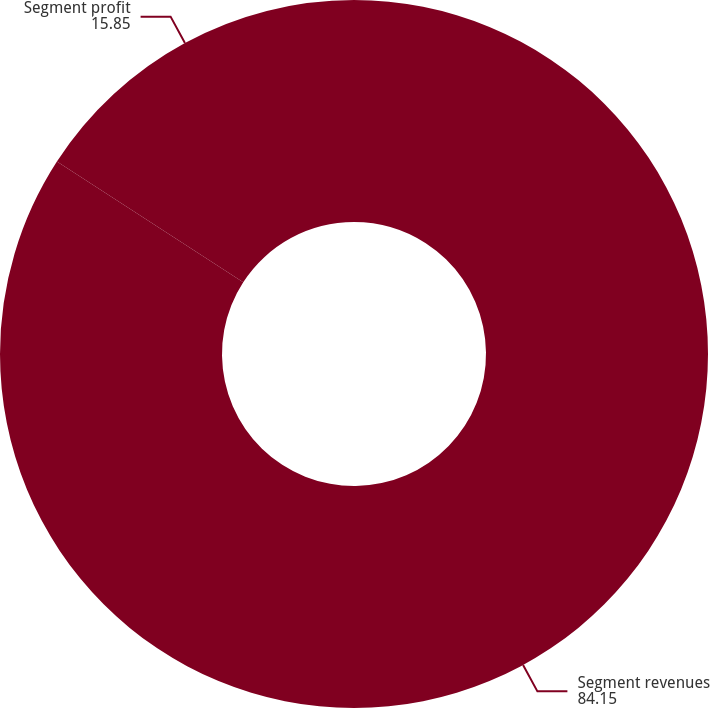<chart> <loc_0><loc_0><loc_500><loc_500><pie_chart><fcel>Segment revenues<fcel>Segment profit<nl><fcel>84.15%<fcel>15.85%<nl></chart> 